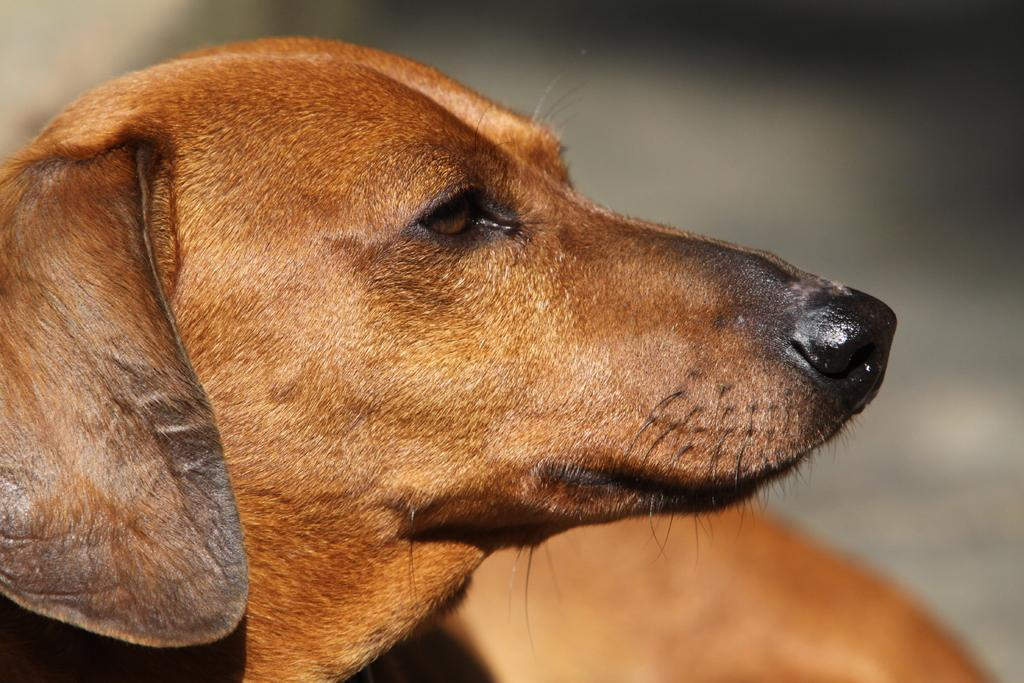What type of creature is present in the image? There is an animal in the image. Can you describe the color of the animal? The animal is brown in color. What can be observed about the background of the image? The background of the image is blurred. What type of peace can be seen in the image? There is no reference to peace in the image, as it features an animal with a blurred background. 